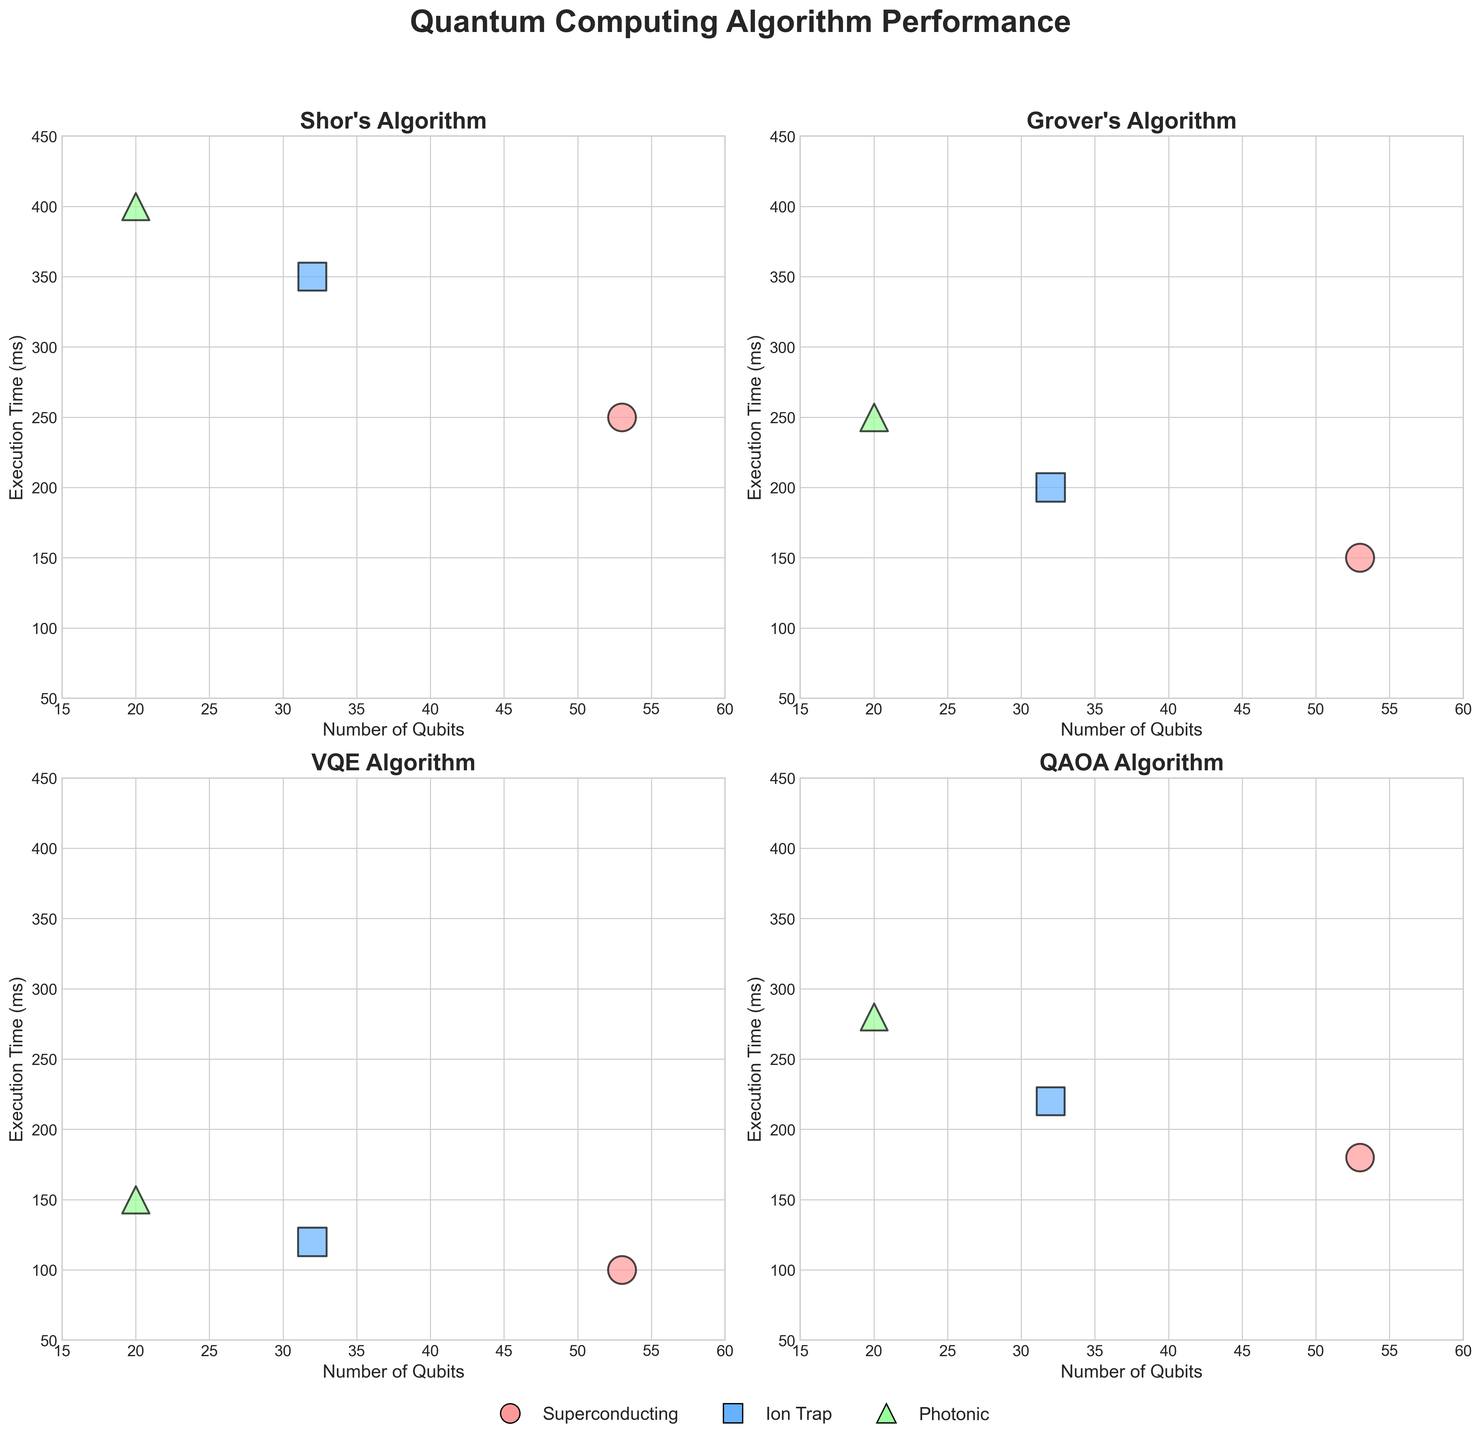How many data points are there for each quantum computing algorithm? There are four subplots, each one representing a different quantum computing algorithm. Within each subplot, there are three architectures represented. Assuming each algorithm-architecture pair has one data point, there are 3 data points for each algorithm.
Answer: 3 What is the execution time for Grover's algorithm using Ion Trap architecture? To find this, locate the subplot for Grover's algorithm and identify the symbol that matches the Ion Trap architecture (which is represented by squares). Read off the execution time from the y-axis using the position of the square marker.
Answer: 200 ms Which algorithm has the highest fidelity under Superconducting architecture? To determine this, look at the size of the markers (as the size represents fidelity) specifically for the circles that correspond to the Superconducting architecture across all subplots. The biggest circle will indicate the highest fidelity. Based on this inspection, Grover's algorithm with a fidelity marker size denoting 0.94 is the highest.
Answer: Grover's Is there a clear trend in execution time as the number of qubits increases for the VQE algorithm? To answer this, observe the subplot for the VQE algorithm. Analyze the distribution of data points along the x-axis (number of qubits) and their corresponding y-axis (execution time). It can be seen that as the number of qubits increases from 20 to 53, the execution time also increases.
Answer: Yes, the execution time increases with the number of qubits Which algorithm and architecture combination has the lowest fidelity? Review all subplots to find the smallest marker (indicating the lowest fidelity). The smallest marker represents QAOA algorithm with Photonic architecture, having a fidelity of 0.87.
Answer: QAOA with Photonic How does the execution time compare between Shor's algorithm and QAOA algorithm for Photonic architecture? Locate the triangle markers in both the Shor's and QAOA subplots. Note their positions on the y-axis for execution time. Shor's algorithm (400 ms) is longer than QAOA (280 ms).
Answer: Shor's is longer What are the number of qubits and execution time for the algorithm-architecture pair with the highest fidelity? Find the largest marker, indicating the highest fidelity (0.97). This corresponds to VQE algorithm using Ion Trap architecture. The x-axis value (number of qubits) is 32, and the y-axis value (execution time) is 120 ms.
Answer: 32 qubits, 120 ms What is the average execution time for Grover's algorithm across all architectures? Identify the execution times for Grover's algorithm from the subplot: 150 ms (Superconducting), 200 ms (Ion Trap), and 250 ms (Photonic). Calculate the average: (150 + 200 + 250)/3 = 600/3 = 200 ms.
Answer: 200 ms 